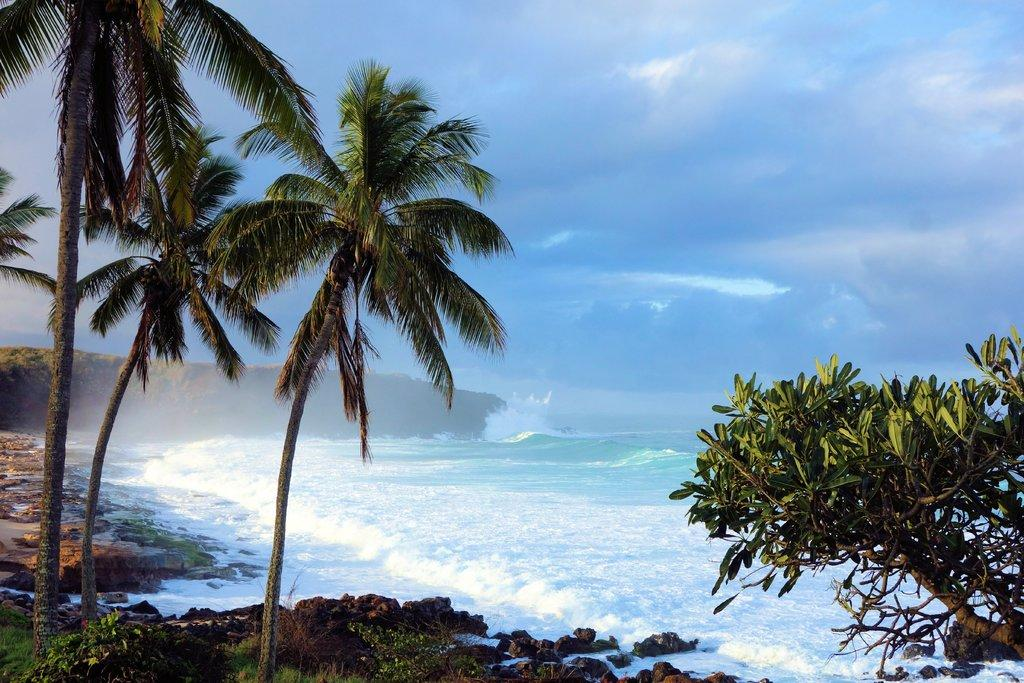What type of living organisms can be seen in the image? Plants can be seen in the image. What other elements are present in the image besides plants? There are rocks and water visible in the image. What can be seen in the sky in the image? Clouds are present in the sky in the image. What type of grape is being used to create harmony in the image? There is no grape or any indication of harmony present in the image. 